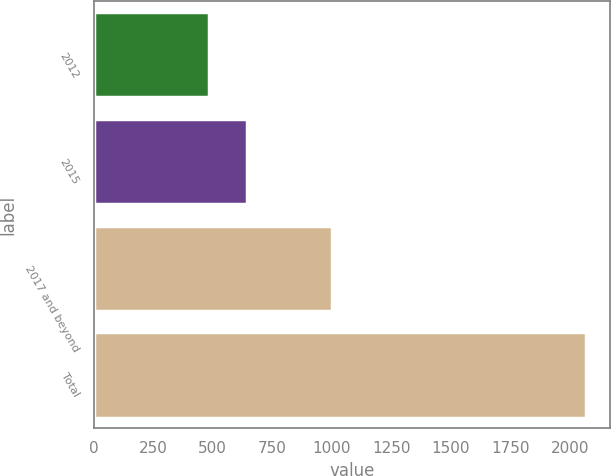Convert chart to OTSL. <chart><loc_0><loc_0><loc_500><loc_500><bar_chart><fcel>2012<fcel>2015<fcel>2017 and beyond<fcel>Total<nl><fcel>485<fcel>643<fcel>1000<fcel>2065<nl></chart> 